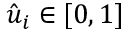<formula> <loc_0><loc_0><loc_500><loc_500>\hat { u } _ { i } \in [ 0 , 1 ]</formula> 